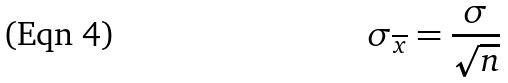<formula> <loc_0><loc_0><loc_500><loc_500>\sigma _ { \overline { x } } = \frac { \sigma } { \sqrt { n } }</formula> 